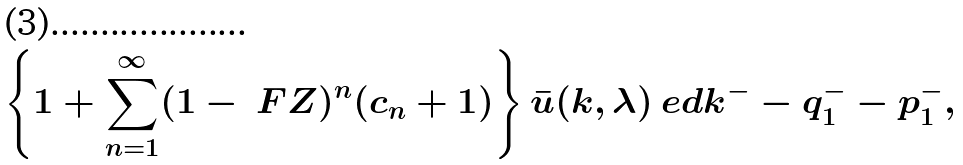Convert formula to latex. <formula><loc_0><loc_0><loc_500><loc_500>\left \{ 1 + \sum _ { n = 1 } ^ { \infty } ( 1 - \ F Z ) ^ { n } ( c _ { n } + 1 ) \right \} \bar { u } ( k , \lambda ) \ e d { k ^ { - } - q _ { 1 } ^ { - } - p _ { 1 } ^ { - } } ,</formula> 